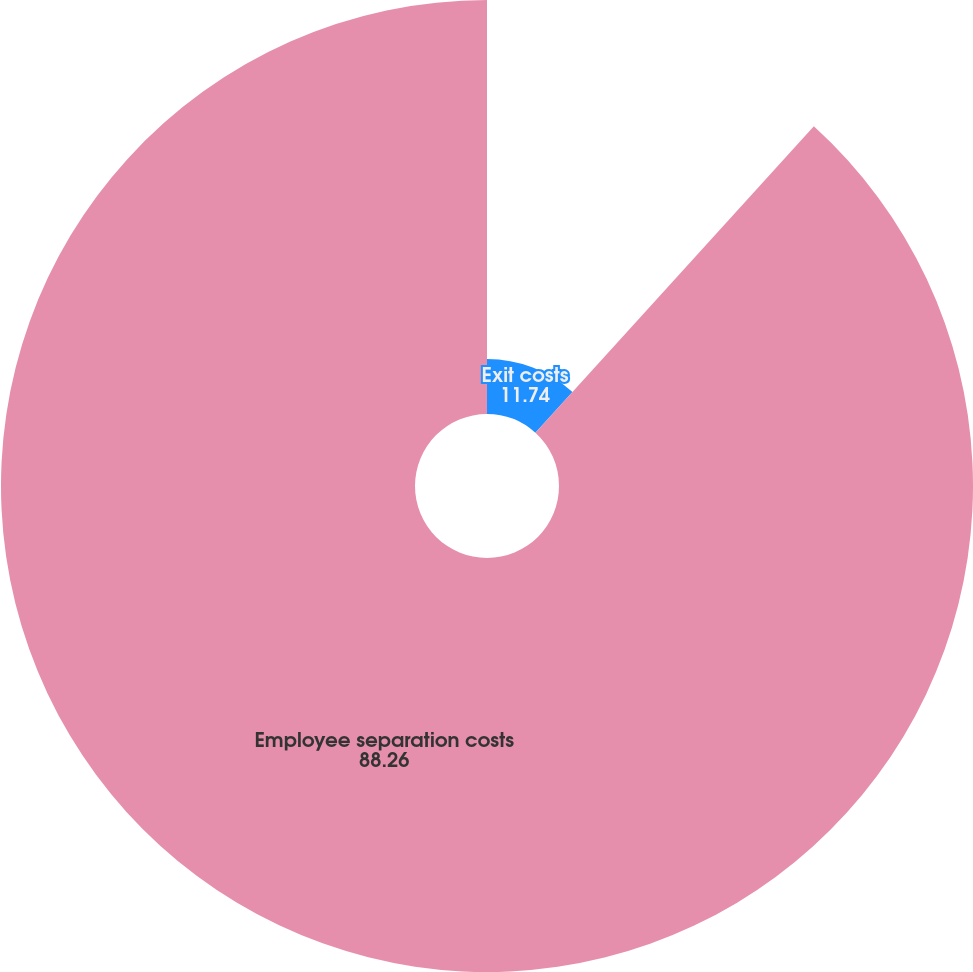Convert chart to OTSL. <chart><loc_0><loc_0><loc_500><loc_500><pie_chart><fcel>Exit costs<fcel>Employee separation costs<nl><fcel>11.74%<fcel>88.26%<nl></chart> 